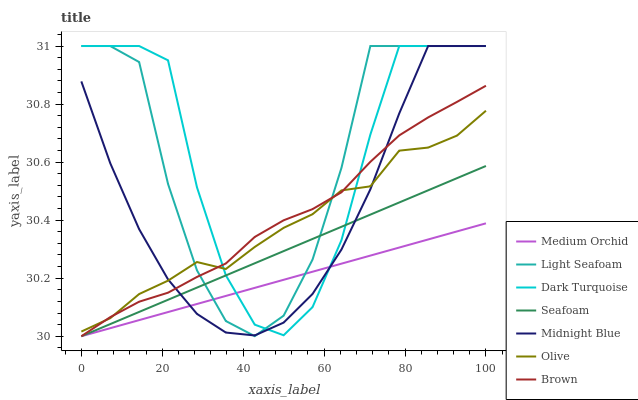Does Medium Orchid have the minimum area under the curve?
Answer yes or no. Yes. Does Dark Turquoise have the maximum area under the curve?
Answer yes or no. Yes. Does Midnight Blue have the minimum area under the curve?
Answer yes or no. No. Does Midnight Blue have the maximum area under the curve?
Answer yes or no. No. Is Medium Orchid the smoothest?
Answer yes or no. Yes. Is Light Seafoam the roughest?
Answer yes or no. Yes. Is Midnight Blue the smoothest?
Answer yes or no. No. Is Midnight Blue the roughest?
Answer yes or no. No. Does Brown have the lowest value?
Answer yes or no. Yes. Does Midnight Blue have the lowest value?
Answer yes or no. No. Does Light Seafoam have the highest value?
Answer yes or no. Yes. Does Medium Orchid have the highest value?
Answer yes or no. No. Is Medium Orchid less than Olive?
Answer yes or no. Yes. Is Olive greater than Seafoam?
Answer yes or no. Yes. Does Light Seafoam intersect Brown?
Answer yes or no. Yes. Is Light Seafoam less than Brown?
Answer yes or no. No. Is Light Seafoam greater than Brown?
Answer yes or no. No. Does Medium Orchid intersect Olive?
Answer yes or no. No. 